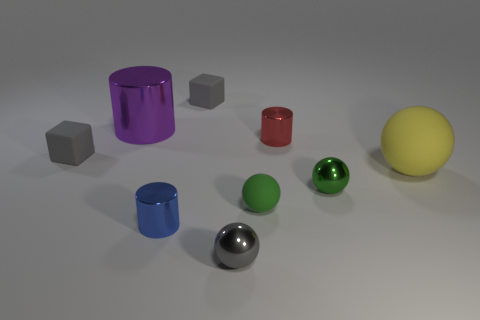Does the purple shiny object have the same size as the metal sphere behind the tiny gray metal ball?
Offer a terse response. No. How many other objects are the same material as the yellow object?
Your response must be concise. 3. What number of things are either tiny gray objects that are behind the big yellow sphere or gray things that are behind the yellow thing?
Provide a succinct answer. 2. What is the material of the small gray object that is the same shape as the big yellow matte object?
Provide a short and direct response. Metal. Are any small red objects visible?
Make the answer very short. Yes. There is a shiny thing that is behind the green metallic object and on the right side of the green matte sphere; what is its size?
Offer a very short reply. Small. What is the shape of the red metallic object?
Provide a succinct answer. Cylinder. There is a matte object behind the red metal cylinder; are there any objects that are in front of it?
Offer a very short reply. Yes. What is the material of the yellow ball that is the same size as the purple cylinder?
Provide a short and direct response. Rubber. Are there any purple rubber cubes that have the same size as the blue shiny object?
Offer a terse response. No. 